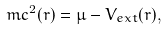<formula> <loc_0><loc_0><loc_500><loc_500>m c ^ { 2 } ( { r } ) = \mu - V _ { e x t } ( { r } ) ,</formula> 